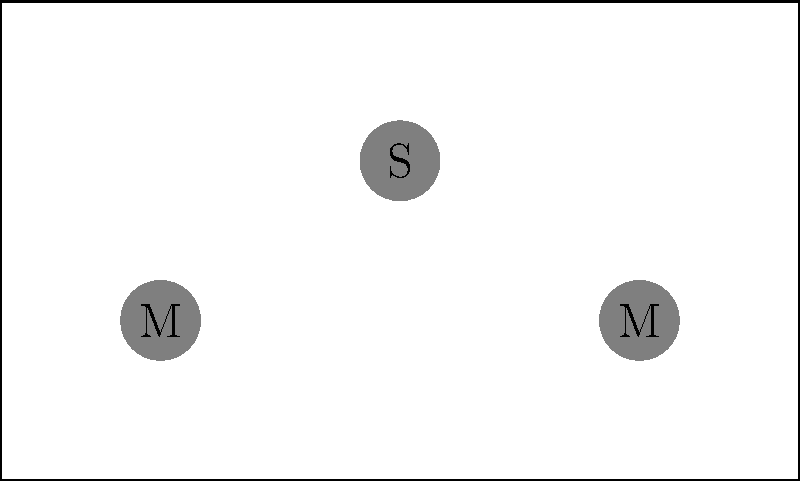Given the virtual stage layout above, where M represents microphones, S represents speakers, and A represents an audio interface, what is the optimal position for placing another speaker to ensure balanced sound distribution for both performers and the audience? To determine the optimal position for an additional speaker, we need to consider the following steps:

1. Analyze the current layout:
   - Two microphones (M) are placed at the front corners of the stage.
   - One speaker (S) is positioned at the center-back of the stage.
   - The audio interface (A) is placed at the front-center of the stage.

2. Consider sound distribution principles:
   - Speakers should be placed symmetrically for balanced sound.
   - They should cover both the stage area (for performers) and the audience area.

3. Identify the gap in coverage:
   - The right side of the stage and audience area lacks direct speaker coverage.

4. Determine the optimal position:
   - To balance the existing speaker, the new speaker should be placed symmetrically opposite to the current one.
   - This position would be at coordinates (5,2) on the stage.

5. Verify the benefits of this position:
   - It creates symmetry with the existing speaker.
   - It provides balanced coverage for both performers on stage and the audience.
   - It avoids potential feedback issues with the microphones.

Therefore, the optimal position for the new speaker is at coordinates (5,2) on the stage, which is the center-front area, mirroring the position of the existing speaker.
Answer: (5,2) 